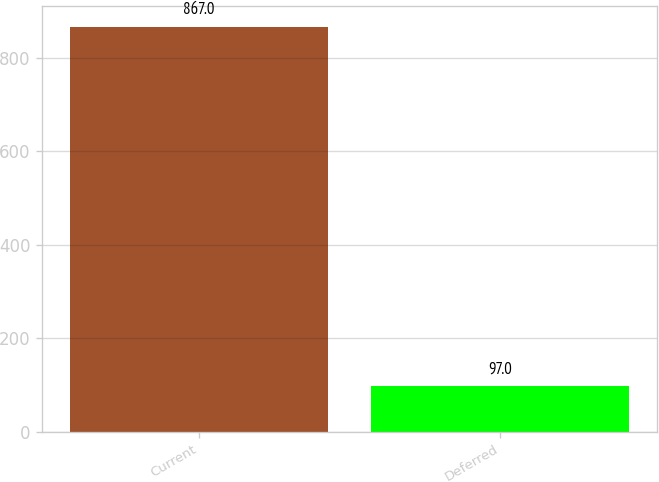<chart> <loc_0><loc_0><loc_500><loc_500><bar_chart><fcel>Current<fcel>Deferred<nl><fcel>867<fcel>97<nl></chart> 